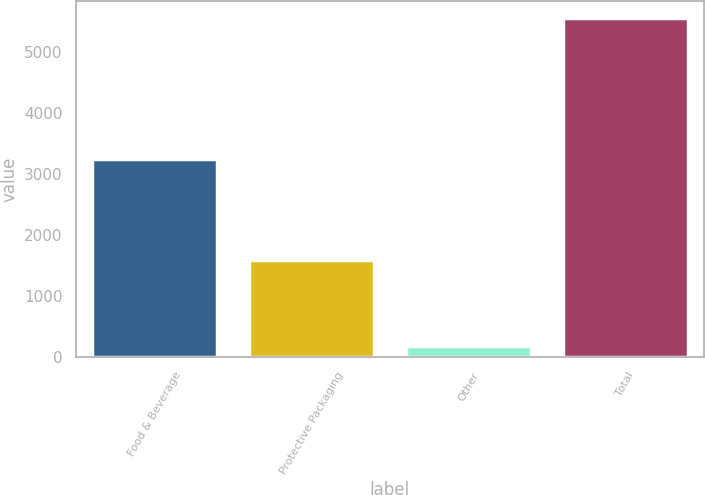Convert chart to OTSL. <chart><loc_0><loc_0><loc_500><loc_500><bar_chart><fcel>Food & Beverage<fcel>Protective Packaging<fcel>Other<fcel>Total<nl><fcel>3240.6<fcel>1594.4<fcel>181.9<fcel>5550.9<nl></chart> 